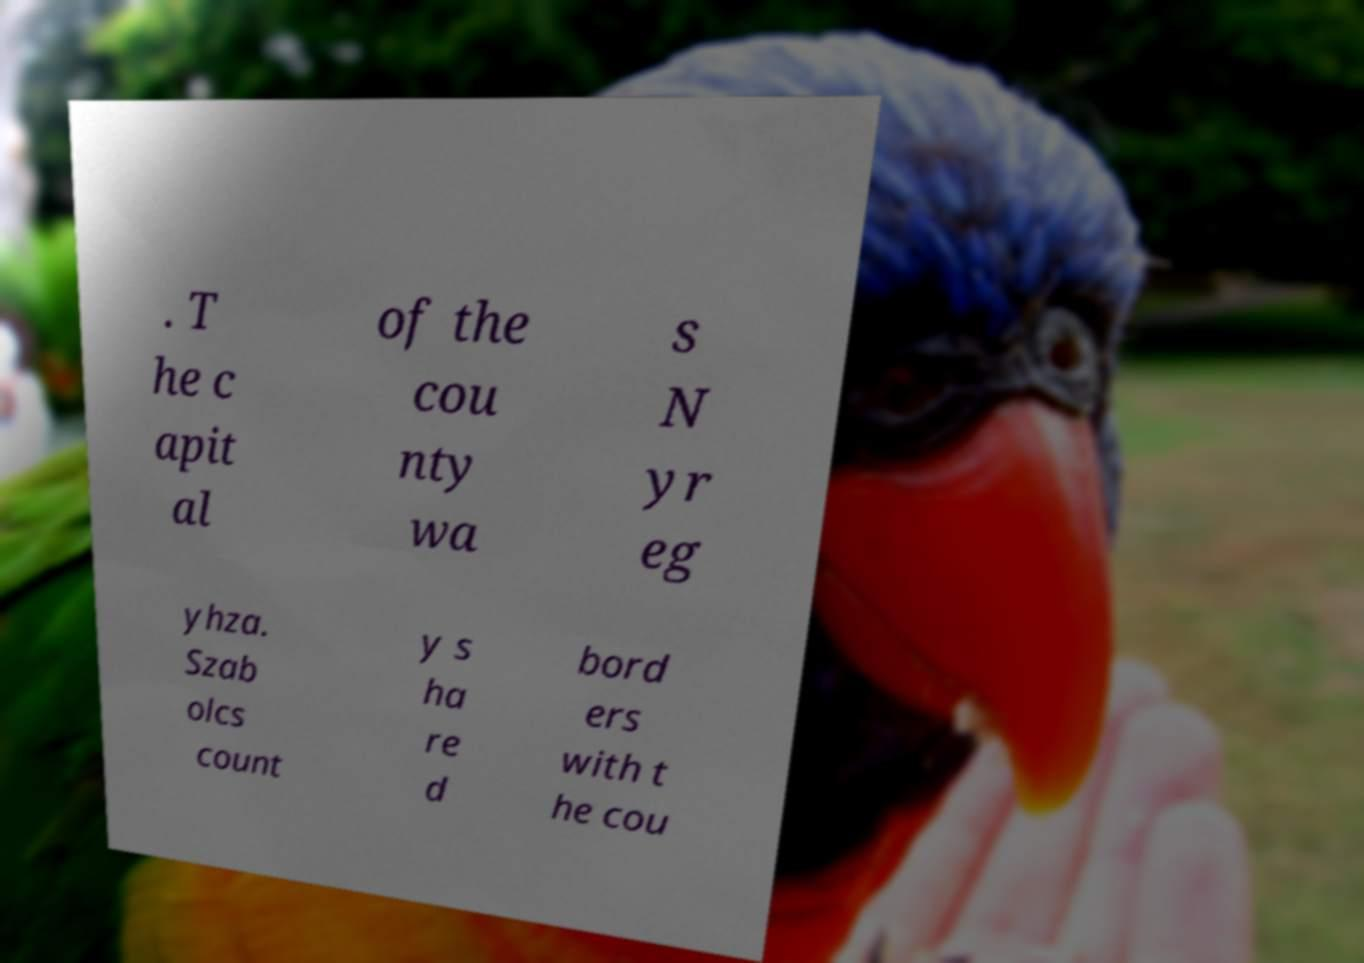What messages or text are displayed in this image? I need them in a readable, typed format. . T he c apit al of the cou nty wa s N yr eg yhza. Szab olcs count y s ha re d bord ers with t he cou 